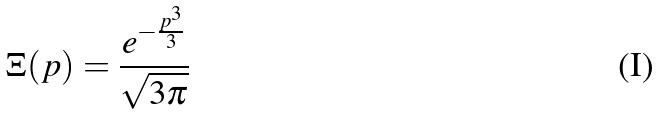<formula> <loc_0><loc_0><loc_500><loc_500>\Xi ( p ) = \frac { e ^ { - \frac { p ^ { 3 } } { 3 } } } { \sqrt { 3 \pi } }</formula> 